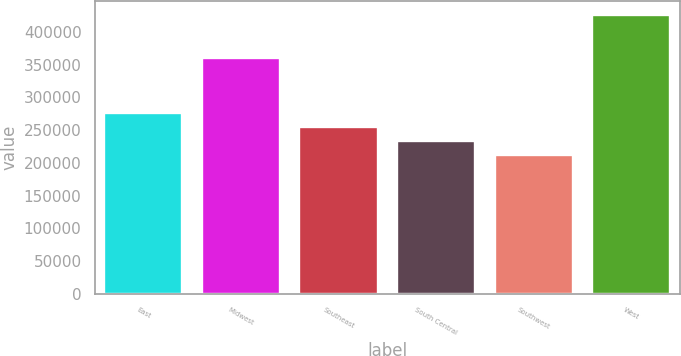Convert chart to OTSL. <chart><loc_0><loc_0><loc_500><loc_500><bar_chart><fcel>East<fcel>Midwest<fcel>Southeast<fcel>South Central<fcel>Southwest<fcel>West<nl><fcel>275860<fcel>359900<fcel>254440<fcel>233020<fcel>211600<fcel>425800<nl></chart> 